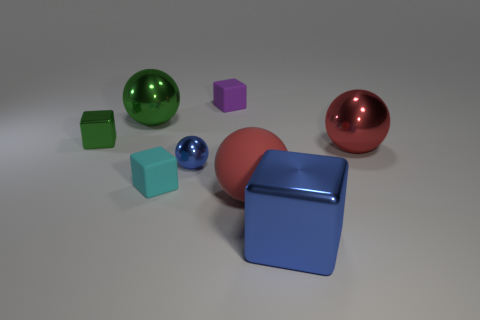Subtract all cyan blocks. How many red balls are left? 2 Subtract all purple blocks. How many blocks are left? 3 Subtract 1 spheres. How many spheres are left? 3 Subtract all green spheres. How many spheres are left? 3 Add 2 cyan matte things. How many objects exist? 10 Subtract all gray blocks. Subtract all red balls. How many blocks are left? 4 Subtract all big red rubber blocks. Subtract all red metal spheres. How many objects are left? 7 Add 1 blue metal cubes. How many blue metal cubes are left? 2 Add 8 small yellow matte balls. How many small yellow matte balls exist? 8 Subtract 0 green cylinders. How many objects are left? 8 